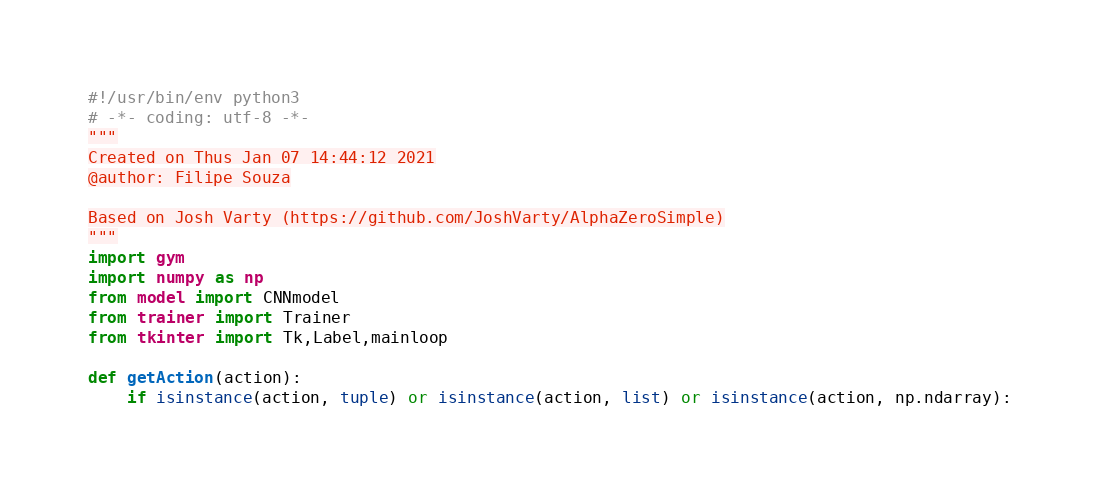Convert code to text. <code><loc_0><loc_0><loc_500><loc_500><_Python_>#!/usr/bin/env python3
# -*- coding: utf-8 -*-
"""
Created on Thus Jan 07 14:44:12 2021
@author: Filipe Souza

Based on Josh Varty (https://github.com/JoshVarty/AlphaZeroSimple)
"""
import gym
import numpy as np
from model import CNNmodel
from trainer import Trainer
from tkinter import Tk,Label,mainloop

def getAction(action):
    if isinstance(action, tuple) or isinstance(action, list) or isinstance(action, np.ndarray):</code> 